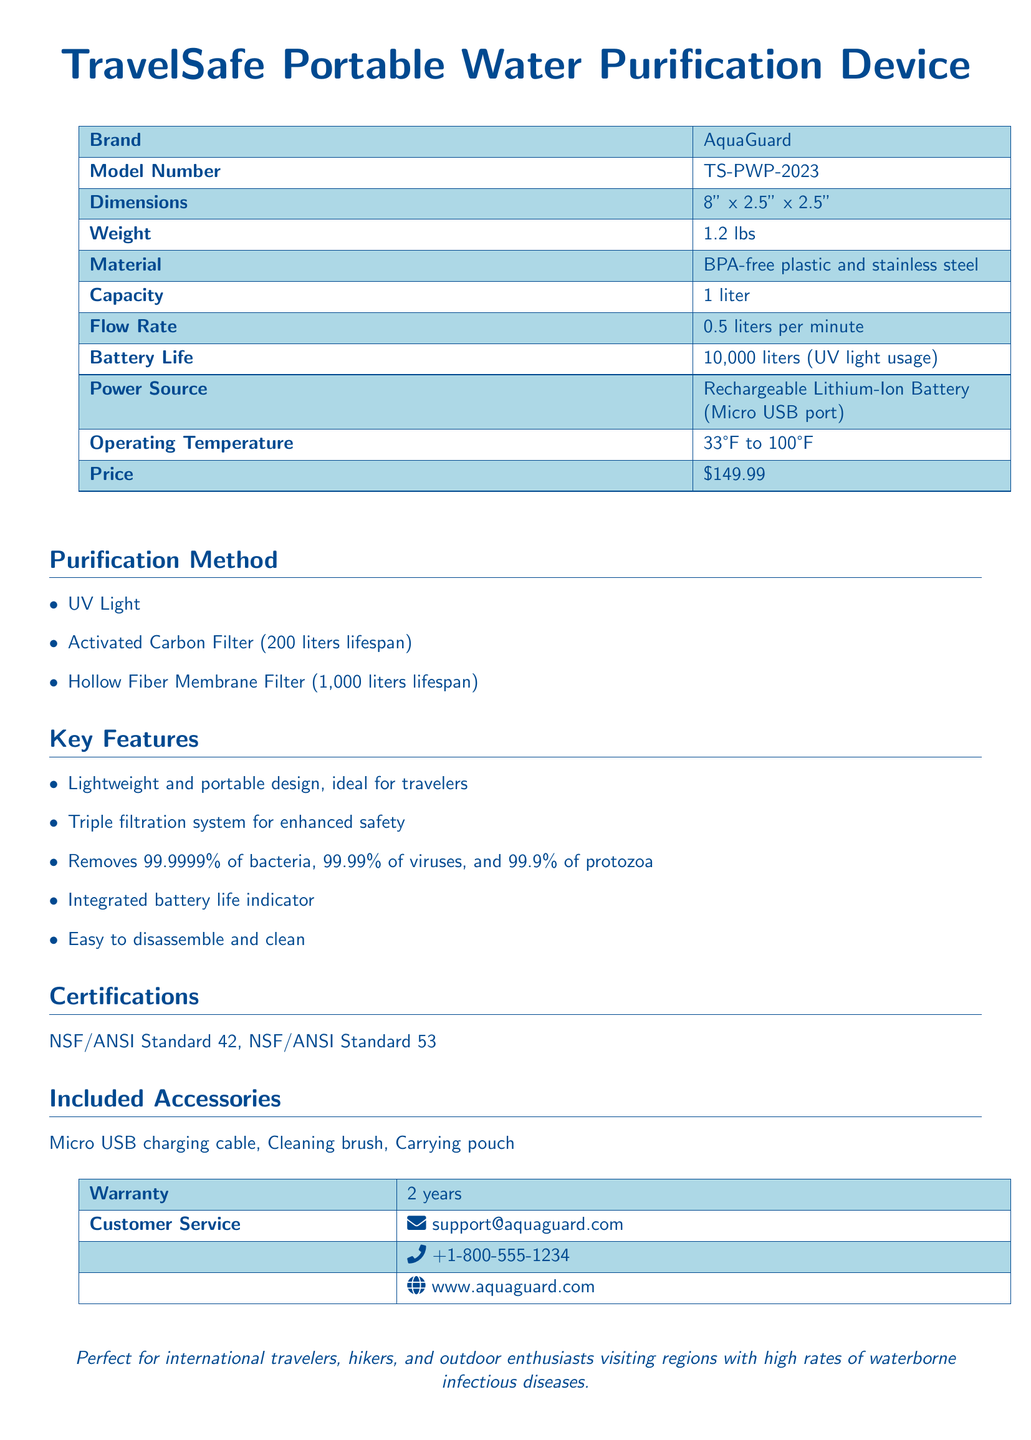what is the brand of the device? The brand of the device is stated in the specifications section of the document.
Answer: AquaGuard what is the model number? The model number can be found under the specifications in the document.
Answer: TS-PWP-2023 what is the weight of the device? The weight is specified in the product specifications area of the document.
Answer: 1.2 lbs what is the capacity of the purification device? The capacity is listed in the specifications section of the document.
Answer: 1 liter how much does the device cost? The price is provided in the specifications section of the document.
Answer: $149.99 what is the lifespan of the activated carbon filter? The lifespan of the activated carbon filter is detailed under the purification method section.
Answer: 200 liters how effective is the device in removing bacteria? The effectiveness against bacteria is mentioned in the key features of the document.
Answer: 99.9999% what is the warranty period for the device? The warranty period is specified in the included accessories section of the document.
Answer: 2 years what is included with the device? The included accessories are listed in a section dedicated to that information.
Answer: Micro USB charging cable, Cleaning brush, Carrying pouch what power source does the device use? The power source for the device is noted in the specifications.
Answer: Rechargeable Lithium-Ion Battery (Micro USB port) 